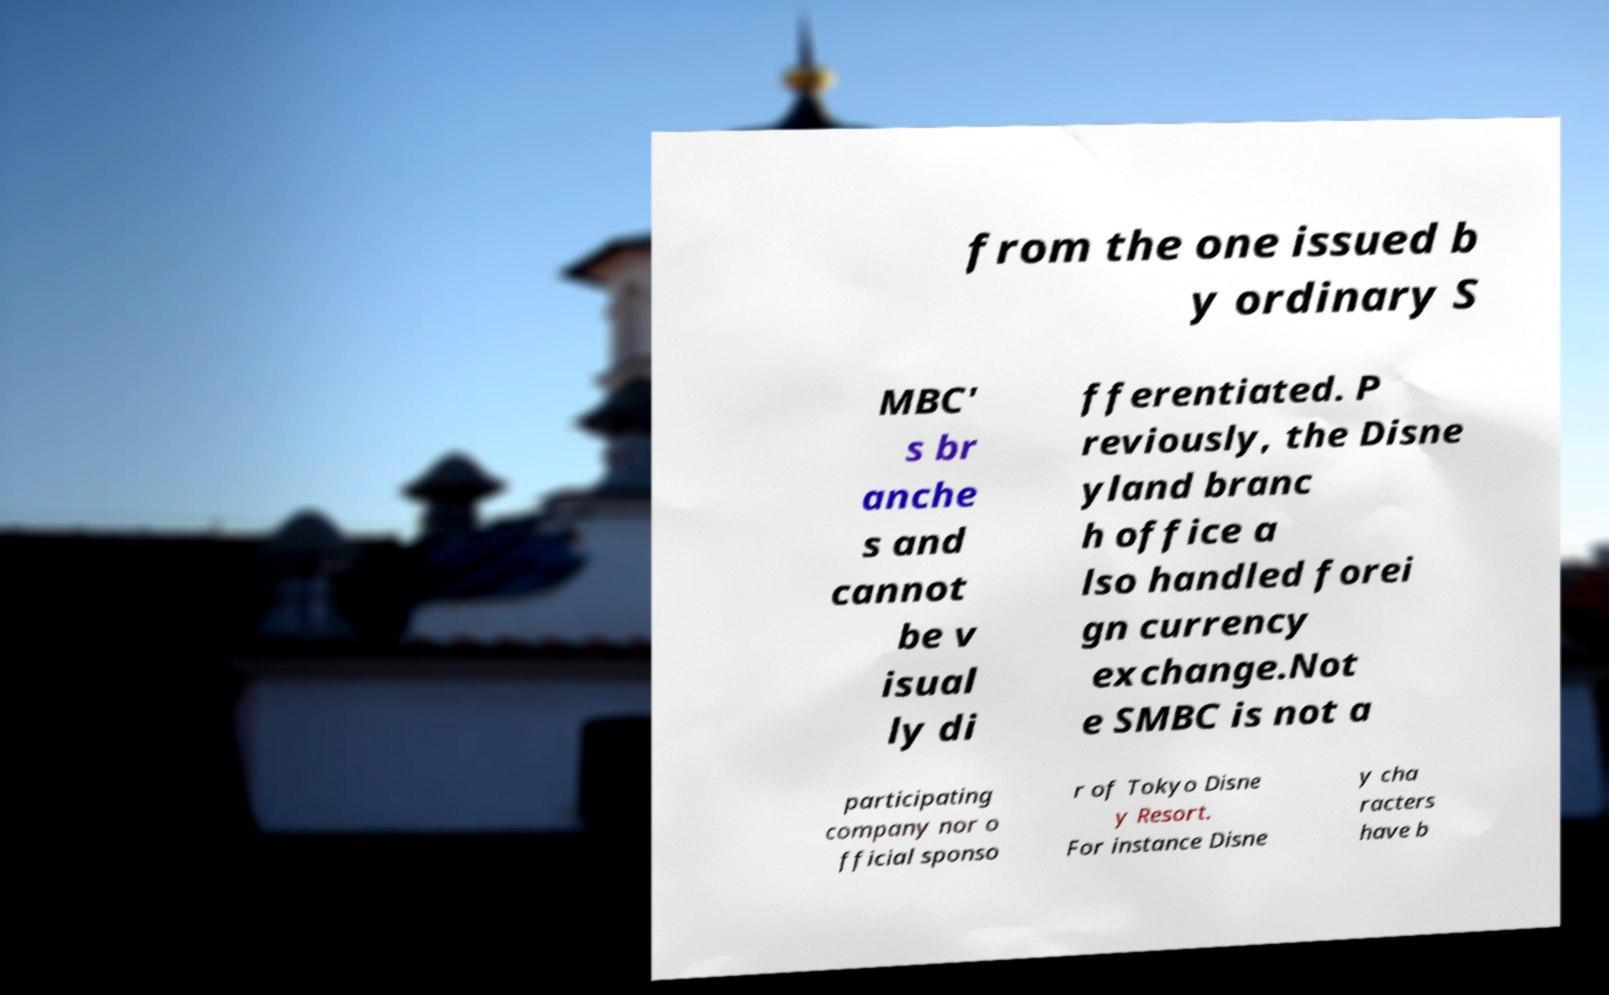Could you assist in decoding the text presented in this image and type it out clearly? from the one issued b y ordinary S MBC' s br anche s and cannot be v isual ly di fferentiated. P reviously, the Disne yland branc h office a lso handled forei gn currency exchange.Not e SMBC is not a participating company nor o fficial sponso r of Tokyo Disne y Resort. For instance Disne y cha racters have b 